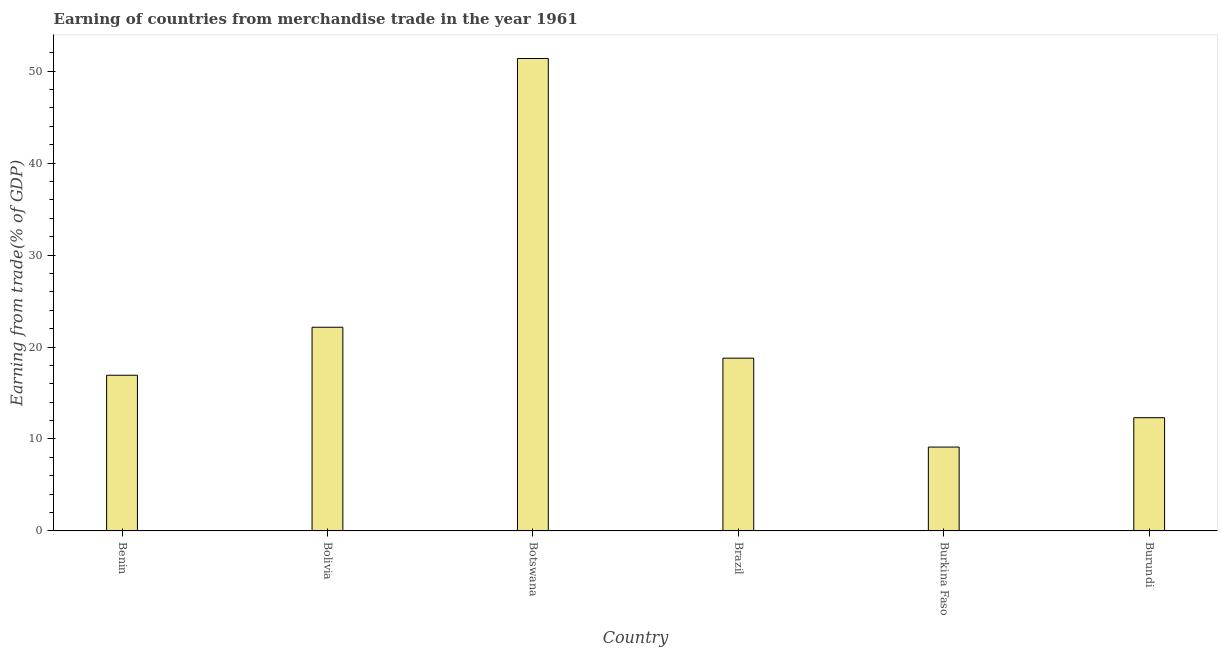What is the title of the graph?
Make the answer very short. Earning of countries from merchandise trade in the year 1961. What is the label or title of the X-axis?
Provide a short and direct response. Country. What is the label or title of the Y-axis?
Provide a short and direct response. Earning from trade(% of GDP). What is the earning from merchandise trade in Botswana?
Your answer should be very brief. 51.38. Across all countries, what is the maximum earning from merchandise trade?
Provide a succinct answer. 51.38. Across all countries, what is the minimum earning from merchandise trade?
Make the answer very short. 9.12. In which country was the earning from merchandise trade maximum?
Your response must be concise. Botswana. In which country was the earning from merchandise trade minimum?
Give a very brief answer. Burkina Faso. What is the sum of the earning from merchandise trade?
Offer a terse response. 130.69. What is the difference between the earning from merchandise trade in Benin and Burundi?
Your answer should be compact. 4.62. What is the average earning from merchandise trade per country?
Offer a very short reply. 21.78. What is the median earning from merchandise trade?
Keep it short and to the point. 17.86. In how many countries, is the earning from merchandise trade greater than 50 %?
Your answer should be very brief. 1. What is the ratio of the earning from merchandise trade in Botswana to that in Burundi?
Your response must be concise. 4.17. Is the difference between the earning from merchandise trade in Botswana and Burundi greater than the difference between any two countries?
Ensure brevity in your answer.  No. What is the difference between the highest and the second highest earning from merchandise trade?
Offer a very short reply. 29.23. Is the sum of the earning from merchandise trade in Benin and Burundi greater than the maximum earning from merchandise trade across all countries?
Give a very brief answer. No. What is the difference between the highest and the lowest earning from merchandise trade?
Offer a terse response. 42.26. How many bars are there?
Offer a terse response. 6. Are all the bars in the graph horizontal?
Keep it short and to the point. No. What is the difference between two consecutive major ticks on the Y-axis?
Your answer should be compact. 10. Are the values on the major ticks of Y-axis written in scientific E-notation?
Offer a terse response. No. What is the Earning from trade(% of GDP) in Benin?
Ensure brevity in your answer.  16.93. What is the Earning from trade(% of GDP) in Bolivia?
Ensure brevity in your answer.  22.15. What is the Earning from trade(% of GDP) in Botswana?
Your answer should be compact. 51.38. What is the Earning from trade(% of GDP) of Brazil?
Your answer should be compact. 18.79. What is the Earning from trade(% of GDP) in Burkina Faso?
Offer a very short reply. 9.12. What is the Earning from trade(% of GDP) in Burundi?
Keep it short and to the point. 12.32. What is the difference between the Earning from trade(% of GDP) in Benin and Bolivia?
Offer a terse response. -5.22. What is the difference between the Earning from trade(% of GDP) in Benin and Botswana?
Provide a succinct answer. -34.45. What is the difference between the Earning from trade(% of GDP) in Benin and Brazil?
Your response must be concise. -1.86. What is the difference between the Earning from trade(% of GDP) in Benin and Burkina Faso?
Keep it short and to the point. 7.81. What is the difference between the Earning from trade(% of GDP) in Benin and Burundi?
Provide a succinct answer. 4.62. What is the difference between the Earning from trade(% of GDP) in Bolivia and Botswana?
Keep it short and to the point. -29.23. What is the difference between the Earning from trade(% of GDP) in Bolivia and Brazil?
Make the answer very short. 3.36. What is the difference between the Earning from trade(% of GDP) in Bolivia and Burkina Faso?
Your response must be concise. 13.03. What is the difference between the Earning from trade(% of GDP) in Bolivia and Burundi?
Ensure brevity in your answer.  9.84. What is the difference between the Earning from trade(% of GDP) in Botswana and Brazil?
Make the answer very short. 32.59. What is the difference between the Earning from trade(% of GDP) in Botswana and Burkina Faso?
Your response must be concise. 42.26. What is the difference between the Earning from trade(% of GDP) in Botswana and Burundi?
Keep it short and to the point. 39.06. What is the difference between the Earning from trade(% of GDP) in Brazil and Burkina Faso?
Give a very brief answer. 9.67. What is the difference between the Earning from trade(% of GDP) in Brazil and Burundi?
Offer a terse response. 6.47. What is the difference between the Earning from trade(% of GDP) in Burkina Faso and Burundi?
Your answer should be compact. -3.19. What is the ratio of the Earning from trade(% of GDP) in Benin to that in Bolivia?
Make the answer very short. 0.76. What is the ratio of the Earning from trade(% of GDP) in Benin to that in Botswana?
Give a very brief answer. 0.33. What is the ratio of the Earning from trade(% of GDP) in Benin to that in Brazil?
Ensure brevity in your answer.  0.9. What is the ratio of the Earning from trade(% of GDP) in Benin to that in Burkina Faso?
Your response must be concise. 1.86. What is the ratio of the Earning from trade(% of GDP) in Benin to that in Burundi?
Your answer should be very brief. 1.38. What is the ratio of the Earning from trade(% of GDP) in Bolivia to that in Botswana?
Your response must be concise. 0.43. What is the ratio of the Earning from trade(% of GDP) in Bolivia to that in Brazil?
Your response must be concise. 1.18. What is the ratio of the Earning from trade(% of GDP) in Bolivia to that in Burkina Faso?
Ensure brevity in your answer.  2.43. What is the ratio of the Earning from trade(% of GDP) in Bolivia to that in Burundi?
Give a very brief answer. 1.8. What is the ratio of the Earning from trade(% of GDP) in Botswana to that in Brazil?
Give a very brief answer. 2.73. What is the ratio of the Earning from trade(% of GDP) in Botswana to that in Burkina Faso?
Provide a short and direct response. 5.63. What is the ratio of the Earning from trade(% of GDP) in Botswana to that in Burundi?
Your answer should be very brief. 4.17. What is the ratio of the Earning from trade(% of GDP) in Brazil to that in Burkina Faso?
Give a very brief answer. 2.06. What is the ratio of the Earning from trade(% of GDP) in Brazil to that in Burundi?
Give a very brief answer. 1.53. What is the ratio of the Earning from trade(% of GDP) in Burkina Faso to that in Burundi?
Keep it short and to the point. 0.74. 